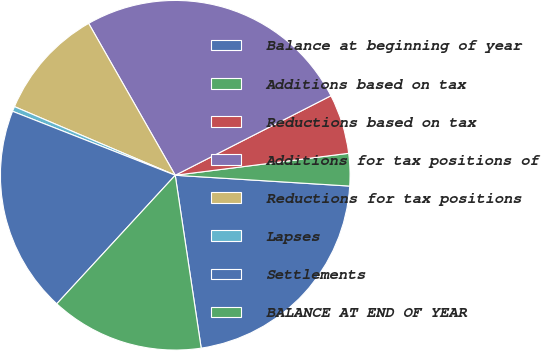<chart> <loc_0><loc_0><loc_500><loc_500><pie_chart><fcel>Balance at beginning of year<fcel>Additions based on tax<fcel>Reductions based on tax<fcel>Additions for tax positions of<fcel>Reductions for tax positions<fcel>Lapses<fcel>Settlements<fcel>BALANCE AT END OF YEAR<nl><fcel>21.64%<fcel>2.99%<fcel>5.51%<fcel>25.73%<fcel>10.33%<fcel>0.46%<fcel>19.11%<fcel>14.22%<nl></chart> 